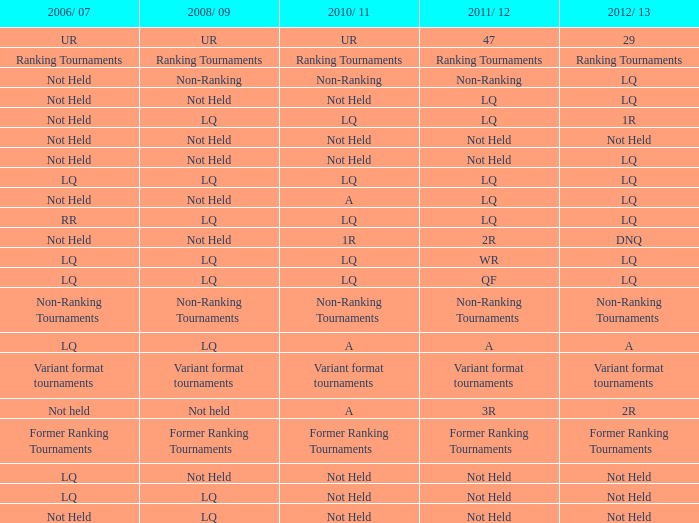What is 2006/07, when 2011/12 is known as lq, and when 2010/11 is identified as lq? Not Held, LQ, RR. 